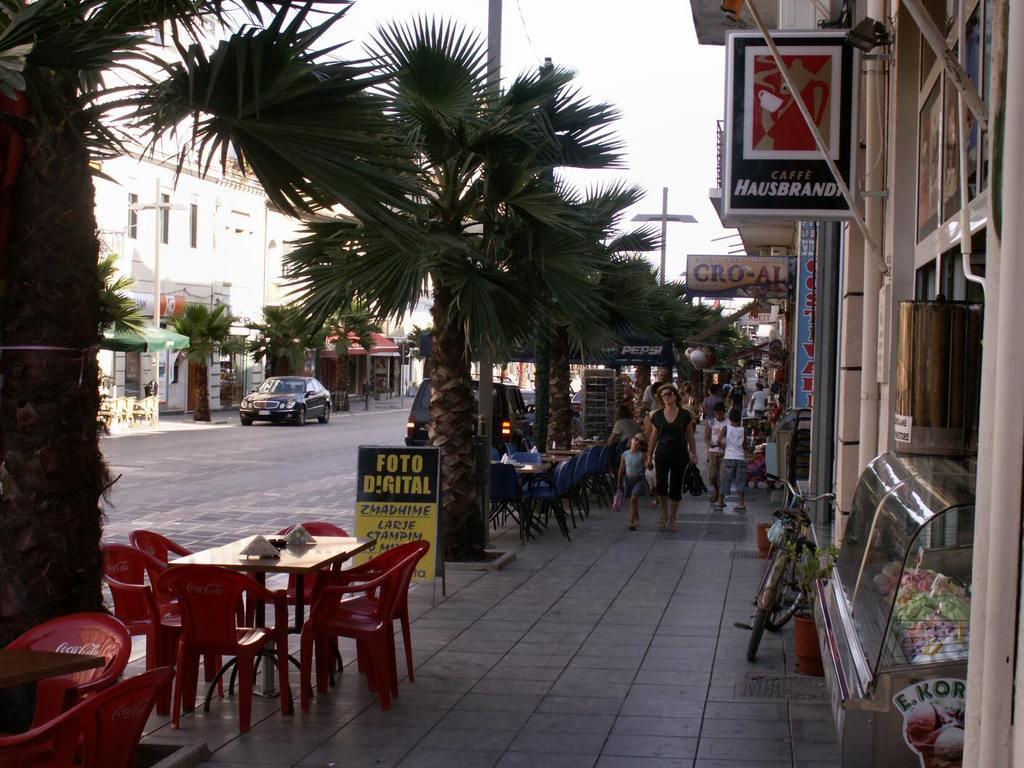Please provide a concise description of this image. in the middle of the image there is a tree. Behind the tree there is a vehicle. In the middle of the image there is a car. Top right side of the image there is a building and banner. Bottom right side of the image there is food store. Behind the store there is a bicycle. In the middle of the image a few people are walking. Bottom left side of the image there is a table, Surrounding the table there are some chairs. Top left side of the image there is a pole, Behind the pole there is a building. 